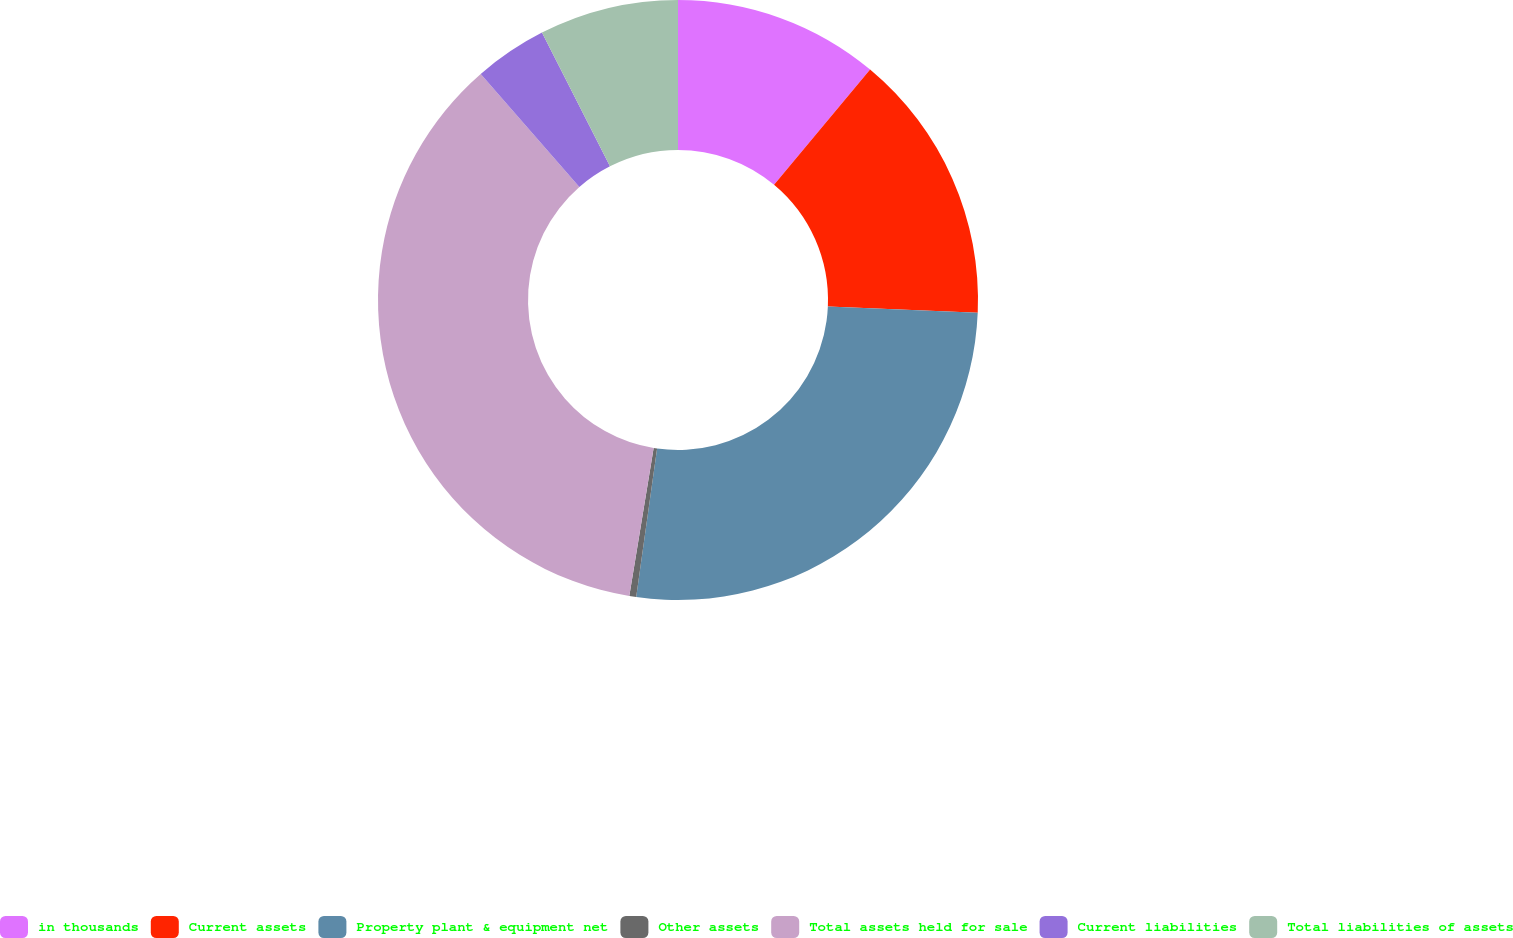Convert chart to OTSL. <chart><loc_0><loc_0><loc_500><loc_500><pie_chart><fcel>in thousands<fcel>Current assets<fcel>Property plant & equipment net<fcel>Other assets<fcel>Total assets held for sale<fcel>Current liabilities<fcel>Total liabilities of assets<nl><fcel>11.06%<fcel>14.62%<fcel>26.54%<fcel>0.37%<fcel>35.98%<fcel>3.93%<fcel>7.49%<nl></chart> 